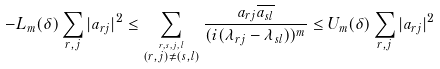Convert formula to latex. <formula><loc_0><loc_0><loc_500><loc_500>- L _ { m } ( \delta ) \sum _ { r , j } | a _ { r j } | ^ { 2 } \leq \sum _ { \stackrel { r , s , j , \, l } { ( r , j ) \neq ( s , l ) } } \frac { a _ { r j } \overline { a _ { s l } } } { ( i ( \lambda _ { r j } - \lambda _ { s l } ) ) ^ { m } } \leq U _ { m } ( \delta ) \sum _ { r , j } | a _ { r j } | ^ { 2 }</formula> 